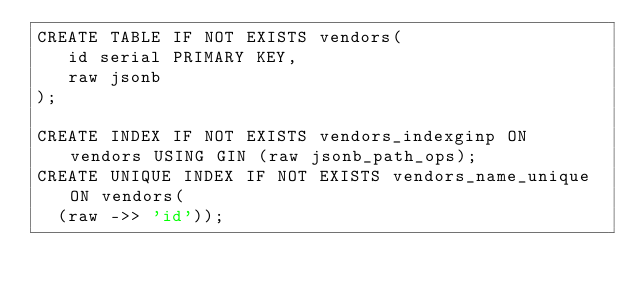Convert code to text. <code><loc_0><loc_0><loc_500><loc_500><_SQL_>CREATE TABLE IF NOT EXISTS vendors(
   id serial PRIMARY KEY,
   raw jsonb
);

CREATE INDEX IF NOT EXISTS vendors_indexginp ON vendors USING GIN (raw jsonb_path_ops);
CREATE UNIQUE INDEX IF NOT EXISTS vendors_name_unique ON vendors(
  (raw ->> 'id'));
</code> 